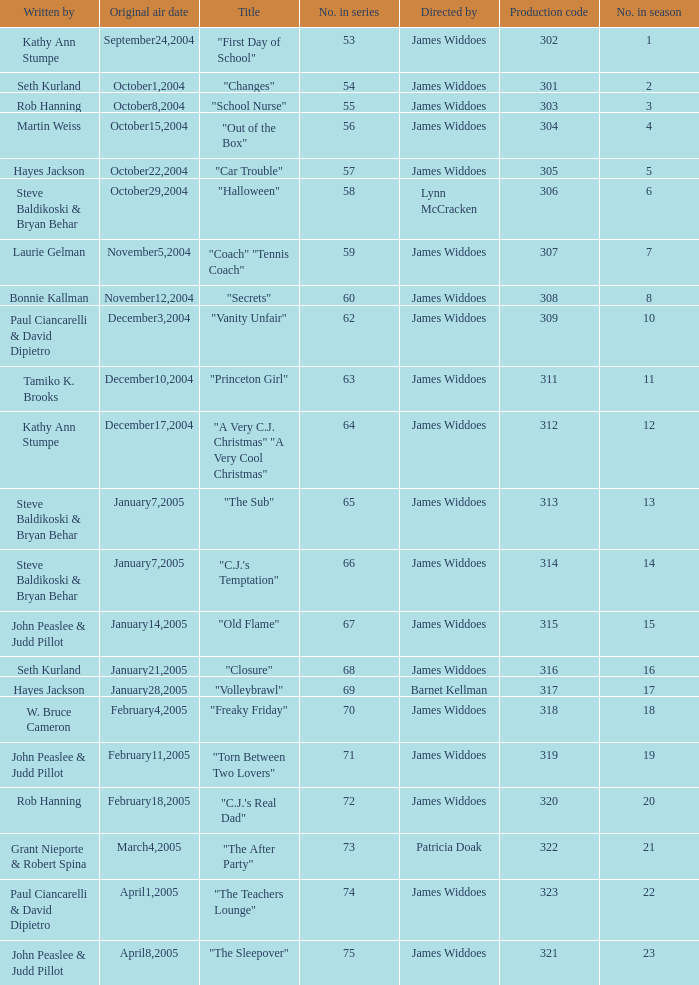What date was the episode originally aired that was directed by James Widdoes and the production code is 320? February18,2005. 